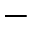<formula> <loc_0><loc_0><loc_500><loc_500>-</formula> 